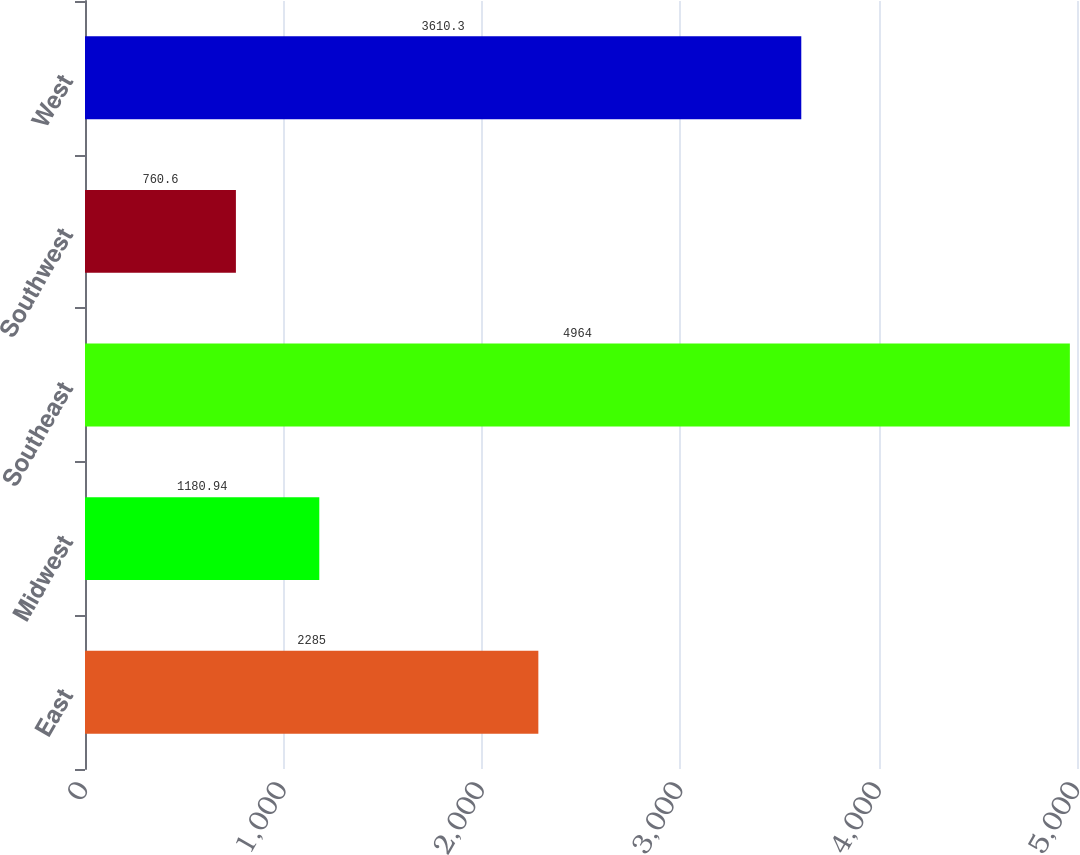Convert chart to OTSL. <chart><loc_0><loc_0><loc_500><loc_500><bar_chart><fcel>East<fcel>Midwest<fcel>Southeast<fcel>Southwest<fcel>West<nl><fcel>2285<fcel>1180.94<fcel>4964<fcel>760.6<fcel>3610.3<nl></chart> 